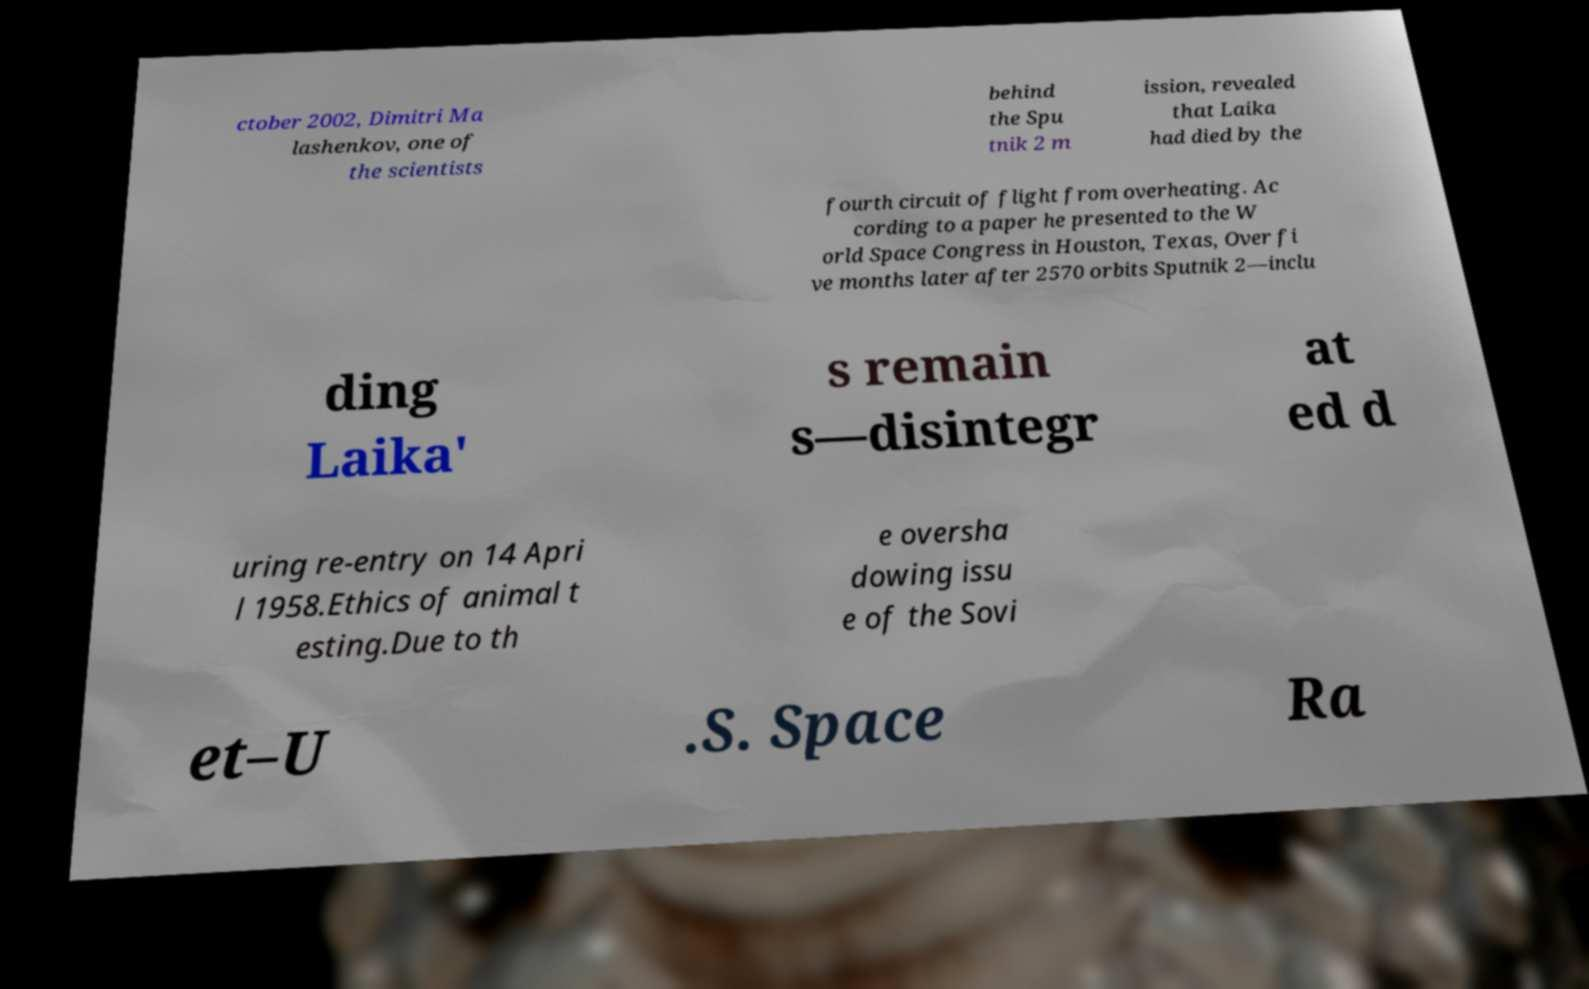I need the written content from this picture converted into text. Can you do that? ctober 2002, Dimitri Ma lashenkov, one of the scientists behind the Spu tnik 2 m ission, revealed that Laika had died by the fourth circuit of flight from overheating. Ac cording to a paper he presented to the W orld Space Congress in Houston, Texas, Over fi ve months later after 2570 orbits Sputnik 2—inclu ding Laika' s remain s—disintegr at ed d uring re-entry on 14 Apri l 1958.Ethics of animal t esting.Due to th e oversha dowing issu e of the Sovi et–U .S. Space Ra 